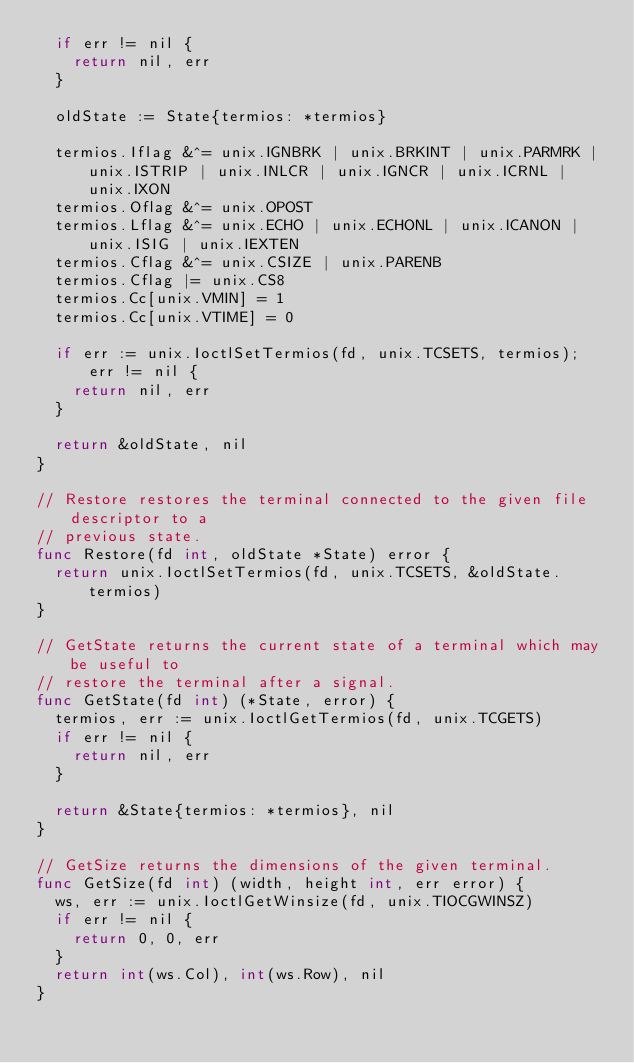<code> <loc_0><loc_0><loc_500><loc_500><_Go_>	if err != nil {
		return nil, err
	}

	oldState := State{termios: *termios}

	termios.Iflag &^= unix.IGNBRK | unix.BRKINT | unix.PARMRK | unix.ISTRIP | unix.INLCR | unix.IGNCR | unix.ICRNL | unix.IXON
	termios.Oflag &^= unix.OPOST
	termios.Lflag &^= unix.ECHO | unix.ECHONL | unix.ICANON | unix.ISIG | unix.IEXTEN
	termios.Cflag &^= unix.CSIZE | unix.PARENB
	termios.Cflag |= unix.CS8
	termios.Cc[unix.VMIN] = 1
	termios.Cc[unix.VTIME] = 0

	if err := unix.IoctlSetTermios(fd, unix.TCSETS, termios); err != nil {
		return nil, err
	}

	return &oldState, nil
}

// Restore restores the terminal connected to the given file descriptor to a
// previous state.
func Restore(fd int, oldState *State) error {
	return unix.IoctlSetTermios(fd, unix.TCSETS, &oldState.termios)
}

// GetState returns the current state of a terminal which may be useful to
// restore the terminal after a signal.
func GetState(fd int) (*State, error) {
	termios, err := unix.IoctlGetTermios(fd, unix.TCGETS)
	if err != nil {
		return nil, err
	}

	return &State{termios: *termios}, nil
}

// GetSize returns the dimensions of the given terminal.
func GetSize(fd int) (width, height int, err error) {
	ws, err := unix.IoctlGetWinsize(fd, unix.TIOCGWINSZ)
	if err != nil {
		return 0, 0, err
	}
	return int(ws.Col), int(ws.Row), nil
}
</code> 